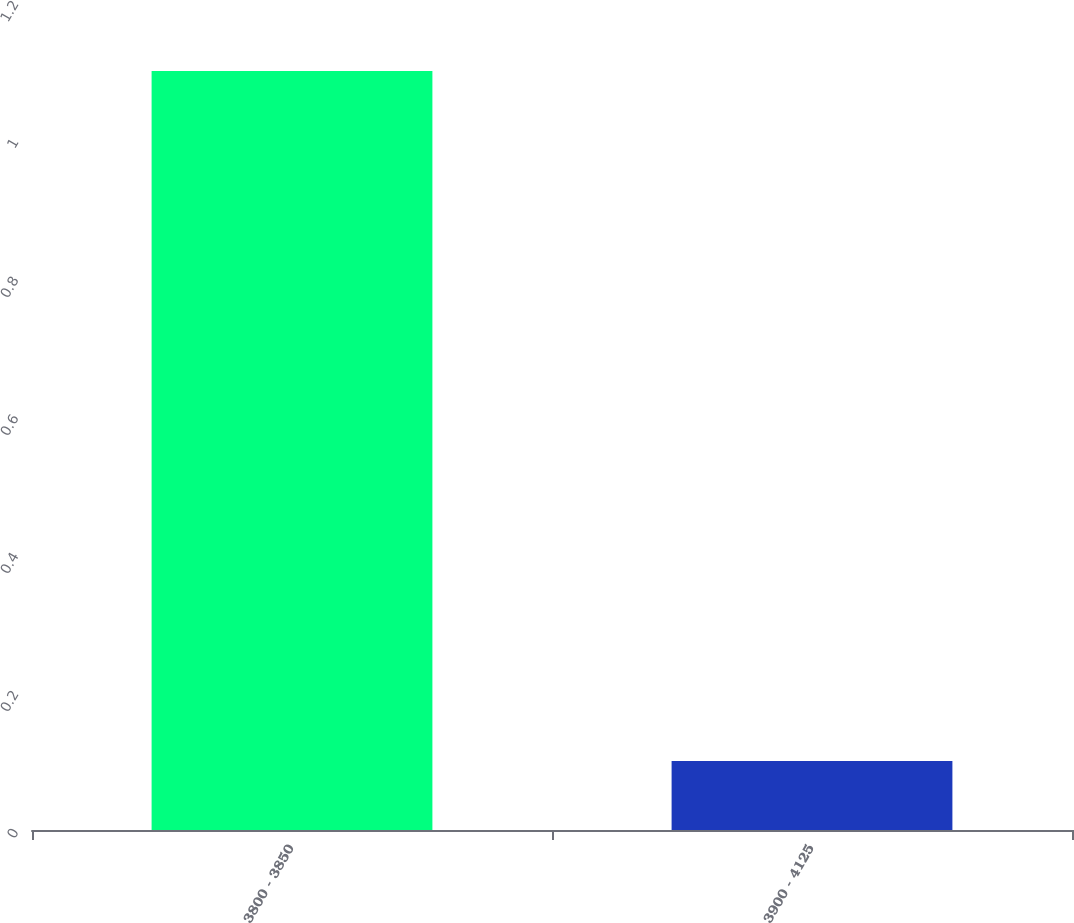<chart> <loc_0><loc_0><loc_500><loc_500><bar_chart><fcel>3800 - 3850<fcel>3900 - 4125<nl><fcel>1.1<fcel>0.1<nl></chart> 